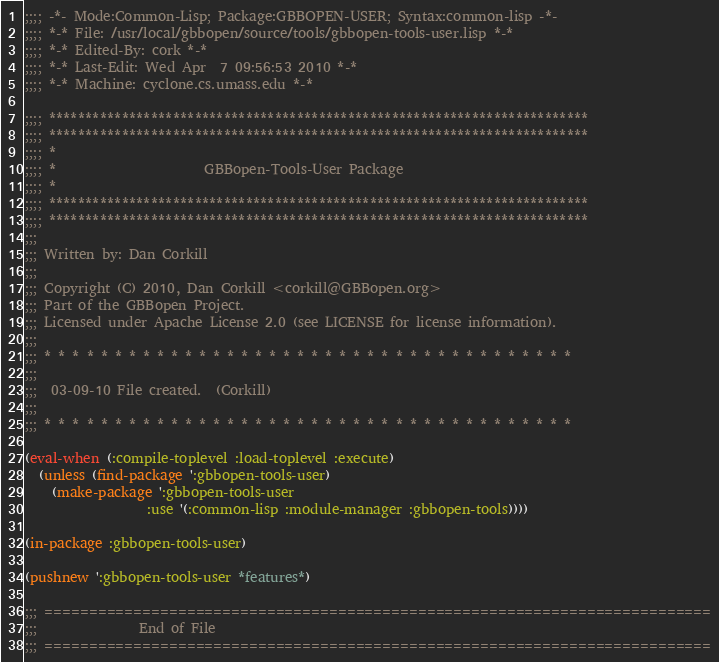Convert code to text. <code><loc_0><loc_0><loc_500><loc_500><_Lisp_>;;;; -*- Mode:Common-Lisp; Package:GBBOPEN-USER; Syntax:common-lisp -*-
;;;; *-* File: /usr/local/gbbopen/source/tools/gbbopen-tools-user.lisp *-*
;;;; *-* Edited-By: cork *-*
;;;; *-* Last-Edit: Wed Apr  7 09:56:53 2010 *-*
;;;; *-* Machine: cyclone.cs.umass.edu *-*

;;;; **************************************************************************
;;;; **************************************************************************
;;;; *
;;;; *                      GBBopen-Tools-User Package
;;;; *
;;;; **************************************************************************
;;;; **************************************************************************
;;;
;;; Written by: Dan Corkill
;;;
;;; Copyright (C) 2010, Dan Corkill <corkill@GBBopen.org>
;;; Part of the GBBopen Project.
;;; Licensed under Apache License 2.0 (see LICENSE for license information).
;;;
;;; * * * * * * * * * * * * * * * * * * * * * * * * * * * * * * * * * * * * * *
;;;
;;;  03-09-10 File created.  (Corkill)
;;;
;;; * * * * * * * * * * * * * * * * * * * * * * * * * * * * * * * * * * * * * *

(eval-when (:compile-toplevel :load-toplevel :execute)
  (unless (find-package ':gbbopen-tools-user)
    (make-package ':gbbopen-tools-user
                  :use '(:common-lisp :module-manager :gbbopen-tools))))

(in-package :gbbopen-tools-user)

(pushnew ':gbbopen-tools-user *features*)

;;; ===========================================================================
;;;				  End of File
;;; ===========================================================================


</code> 